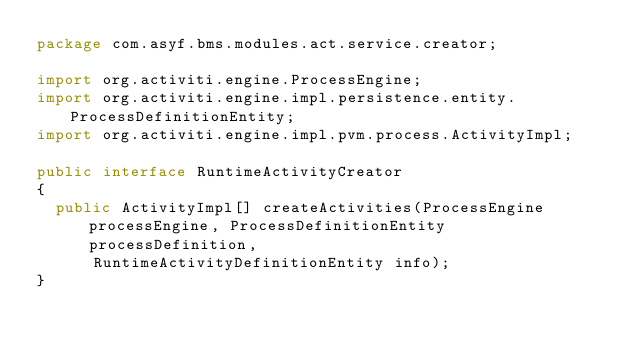<code> <loc_0><loc_0><loc_500><loc_500><_Java_>package com.asyf.bms.modules.act.service.creator;

import org.activiti.engine.ProcessEngine;
import org.activiti.engine.impl.persistence.entity.ProcessDefinitionEntity;
import org.activiti.engine.impl.pvm.process.ActivityImpl;

public interface RuntimeActivityCreator
{
	public ActivityImpl[] createActivities(ProcessEngine processEngine, ProcessDefinitionEntity processDefinition,
			RuntimeActivityDefinitionEntity info);
}</code> 